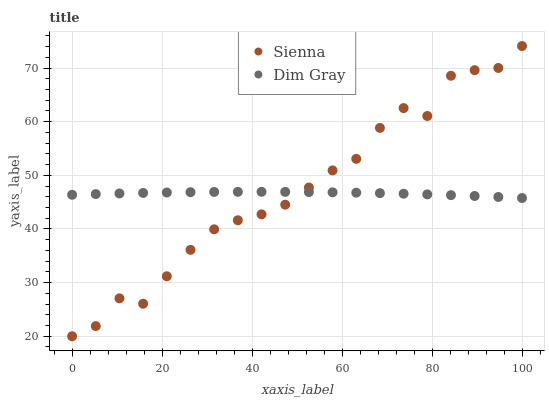Does Dim Gray have the minimum area under the curve?
Answer yes or no. Yes. Does Sienna have the maximum area under the curve?
Answer yes or no. Yes. Does Dim Gray have the maximum area under the curve?
Answer yes or no. No. Is Dim Gray the smoothest?
Answer yes or no. Yes. Is Sienna the roughest?
Answer yes or no. Yes. Is Dim Gray the roughest?
Answer yes or no. No. Does Sienna have the lowest value?
Answer yes or no. Yes. Does Dim Gray have the lowest value?
Answer yes or no. No. Does Sienna have the highest value?
Answer yes or no. Yes. Does Dim Gray have the highest value?
Answer yes or no. No. Does Dim Gray intersect Sienna?
Answer yes or no. Yes. Is Dim Gray less than Sienna?
Answer yes or no. No. Is Dim Gray greater than Sienna?
Answer yes or no. No. 